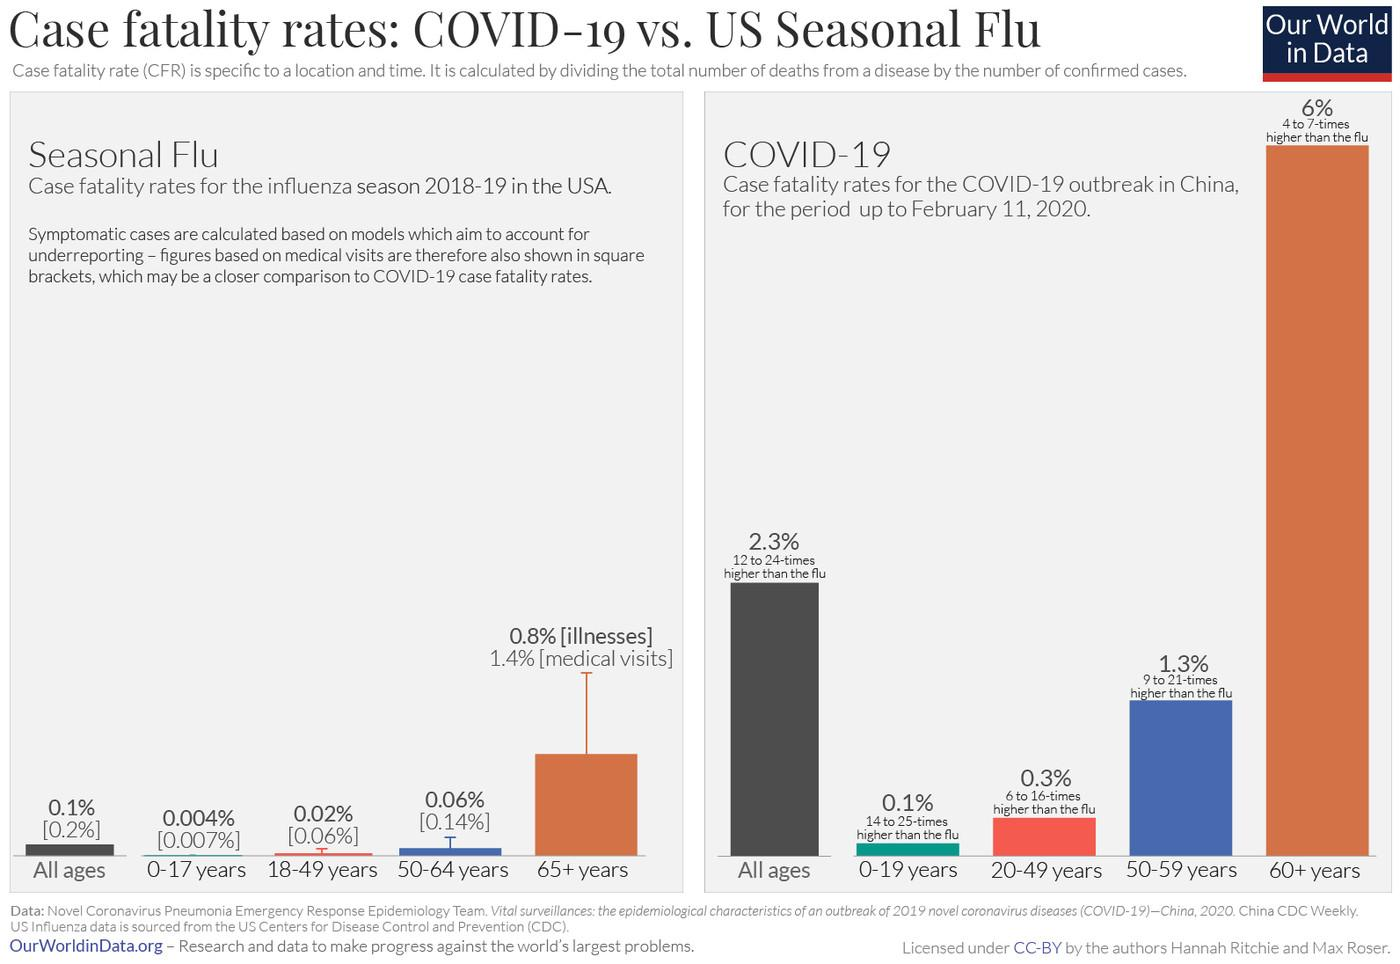Highlight a few significant elements in this photo. According to recent data, only 0.8% of senior citizens are affected by seasonal flu. 